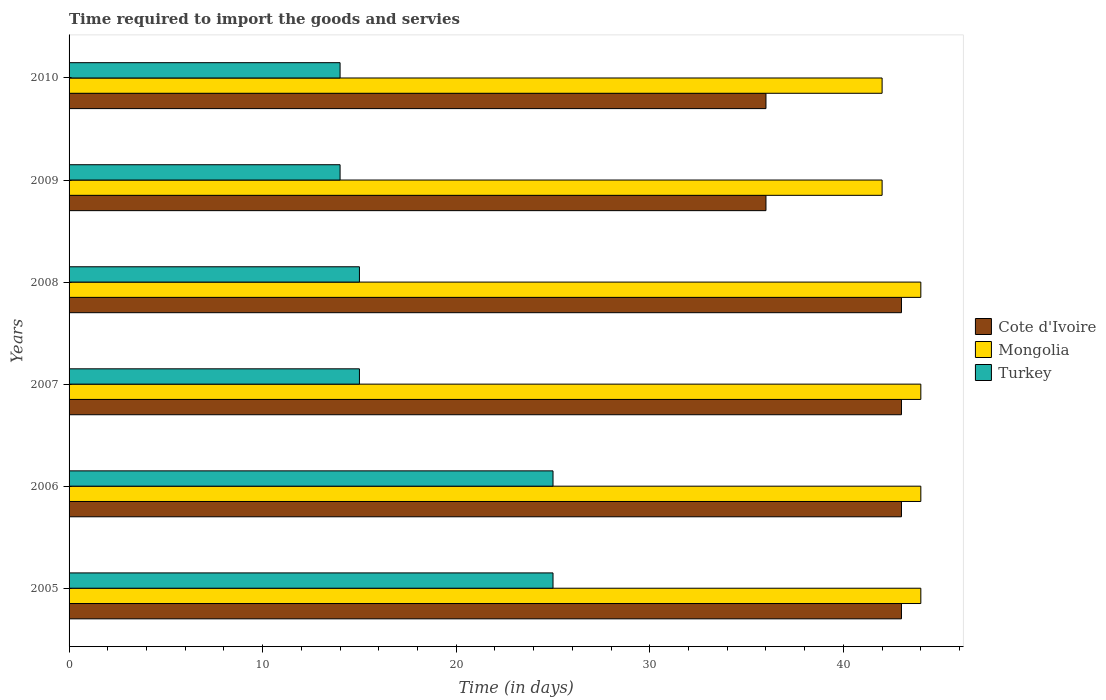How many bars are there on the 6th tick from the bottom?
Your answer should be very brief. 3. In how many cases, is the number of bars for a given year not equal to the number of legend labels?
Your answer should be very brief. 0. What is the number of days required to import the goods and services in Turkey in 2007?
Offer a terse response. 15. Across all years, what is the maximum number of days required to import the goods and services in Turkey?
Offer a terse response. 25. Across all years, what is the minimum number of days required to import the goods and services in Cote d'Ivoire?
Offer a very short reply. 36. In which year was the number of days required to import the goods and services in Turkey maximum?
Ensure brevity in your answer.  2005. In which year was the number of days required to import the goods and services in Cote d'Ivoire minimum?
Keep it short and to the point. 2009. What is the total number of days required to import the goods and services in Cote d'Ivoire in the graph?
Your answer should be compact. 244. What is the difference between the number of days required to import the goods and services in Cote d'Ivoire in 2007 and that in 2008?
Give a very brief answer. 0. What is the difference between the number of days required to import the goods and services in Turkey in 2006 and the number of days required to import the goods and services in Mongolia in 2009?
Provide a short and direct response. -17. What is the average number of days required to import the goods and services in Turkey per year?
Provide a short and direct response. 18. In the year 2010, what is the difference between the number of days required to import the goods and services in Cote d'Ivoire and number of days required to import the goods and services in Turkey?
Make the answer very short. 22. In how many years, is the number of days required to import the goods and services in Turkey greater than 38 days?
Give a very brief answer. 0. What is the ratio of the number of days required to import the goods and services in Cote d'Ivoire in 2009 to that in 2010?
Your answer should be very brief. 1. Is the number of days required to import the goods and services in Cote d'Ivoire in 2005 less than that in 2006?
Give a very brief answer. No. Is the difference between the number of days required to import the goods and services in Cote d'Ivoire in 2005 and 2008 greater than the difference between the number of days required to import the goods and services in Turkey in 2005 and 2008?
Offer a very short reply. No. What is the difference between the highest and the lowest number of days required to import the goods and services in Mongolia?
Provide a succinct answer. 2. What does the 2nd bar from the top in 2009 represents?
Ensure brevity in your answer.  Mongolia. What does the 1st bar from the bottom in 2007 represents?
Provide a short and direct response. Cote d'Ivoire. Is it the case that in every year, the sum of the number of days required to import the goods and services in Mongolia and number of days required to import the goods and services in Turkey is greater than the number of days required to import the goods and services in Cote d'Ivoire?
Your answer should be compact. Yes. How many bars are there?
Your answer should be compact. 18. Are all the bars in the graph horizontal?
Make the answer very short. Yes. How many years are there in the graph?
Provide a succinct answer. 6. Are the values on the major ticks of X-axis written in scientific E-notation?
Ensure brevity in your answer.  No. Does the graph contain any zero values?
Your answer should be very brief. No. Does the graph contain grids?
Ensure brevity in your answer.  No. Where does the legend appear in the graph?
Provide a short and direct response. Center right. How many legend labels are there?
Make the answer very short. 3. What is the title of the graph?
Your answer should be very brief. Time required to import the goods and servies. What is the label or title of the X-axis?
Offer a terse response. Time (in days). What is the Time (in days) in Cote d'Ivoire in 2007?
Ensure brevity in your answer.  43. What is the Time (in days) in Mongolia in 2007?
Provide a short and direct response. 44. What is the Time (in days) in Turkey in 2007?
Your response must be concise. 15. What is the Time (in days) of Cote d'Ivoire in 2008?
Provide a succinct answer. 43. What is the Time (in days) in Turkey in 2008?
Provide a succinct answer. 15. What is the Time (in days) of Cote d'Ivoire in 2009?
Keep it short and to the point. 36. What is the Time (in days) of Cote d'Ivoire in 2010?
Give a very brief answer. 36. What is the Time (in days) of Turkey in 2010?
Provide a short and direct response. 14. Across all years, what is the maximum Time (in days) in Turkey?
Your answer should be compact. 25. Across all years, what is the minimum Time (in days) in Cote d'Ivoire?
Make the answer very short. 36. What is the total Time (in days) of Cote d'Ivoire in the graph?
Your answer should be compact. 244. What is the total Time (in days) of Mongolia in the graph?
Make the answer very short. 260. What is the total Time (in days) of Turkey in the graph?
Provide a succinct answer. 108. What is the difference between the Time (in days) in Turkey in 2005 and that in 2006?
Provide a succinct answer. 0. What is the difference between the Time (in days) of Cote d'Ivoire in 2005 and that in 2007?
Ensure brevity in your answer.  0. What is the difference between the Time (in days) in Mongolia in 2005 and that in 2007?
Give a very brief answer. 0. What is the difference between the Time (in days) of Cote d'Ivoire in 2005 and that in 2008?
Offer a terse response. 0. What is the difference between the Time (in days) in Mongolia in 2005 and that in 2009?
Provide a succinct answer. 2. What is the difference between the Time (in days) in Cote d'Ivoire in 2005 and that in 2010?
Give a very brief answer. 7. What is the difference between the Time (in days) of Turkey in 2005 and that in 2010?
Your response must be concise. 11. What is the difference between the Time (in days) in Turkey in 2006 and that in 2007?
Provide a succinct answer. 10. What is the difference between the Time (in days) in Turkey in 2006 and that in 2008?
Provide a short and direct response. 10. What is the difference between the Time (in days) in Cote d'Ivoire in 2006 and that in 2009?
Your answer should be compact. 7. What is the difference between the Time (in days) of Turkey in 2006 and that in 2009?
Your answer should be compact. 11. What is the difference between the Time (in days) in Cote d'Ivoire in 2006 and that in 2010?
Offer a very short reply. 7. What is the difference between the Time (in days) of Mongolia in 2006 and that in 2010?
Your response must be concise. 2. What is the difference between the Time (in days) in Turkey in 2006 and that in 2010?
Your response must be concise. 11. What is the difference between the Time (in days) of Turkey in 2007 and that in 2008?
Your response must be concise. 0. What is the difference between the Time (in days) of Cote d'Ivoire in 2007 and that in 2009?
Offer a terse response. 7. What is the difference between the Time (in days) in Turkey in 2007 and that in 2009?
Ensure brevity in your answer.  1. What is the difference between the Time (in days) of Cote d'Ivoire in 2007 and that in 2010?
Your response must be concise. 7. What is the difference between the Time (in days) in Mongolia in 2007 and that in 2010?
Keep it short and to the point. 2. What is the difference between the Time (in days) in Mongolia in 2008 and that in 2009?
Your response must be concise. 2. What is the difference between the Time (in days) of Turkey in 2008 and that in 2009?
Your answer should be compact. 1. What is the difference between the Time (in days) in Cote d'Ivoire in 2008 and that in 2010?
Make the answer very short. 7. What is the difference between the Time (in days) in Mongolia in 2008 and that in 2010?
Provide a short and direct response. 2. What is the difference between the Time (in days) in Mongolia in 2009 and that in 2010?
Your answer should be very brief. 0. What is the difference between the Time (in days) in Cote d'Ivoire in 2005 and the Time (in days) in Turkey in 2006?
Provide a succinct answer. 18. What is the difference between the Time (in days) of Cote d'Ivoire in 2005 and the Time (in days) of Mongolia in 2007?
Give a very brief answer. -1. What is the difference between the Time (in days) in Cote d'Ivoire in 2005 and the Time (in days) in Mongolia in 2008?
Ensure brevity in your answer.  -1. What is the difference between the Time (in days) of Cote d'Ivoire in 2005 and the Time (in days) of Turkey in 2008?
Offer a terse response. 28. What is the difference between the Time (in days) of Mongolia in 2005 and the Time (in days) of Turkey in 2008?
Your answer should be very brief. 29. What is the difference between the Time (in days) of Cote d'Ivoire in 2005 and the Time (in days) of Turkey in 2009?
Ensure brevity in your answer.  29. What is the difference between the Time (in days) of Cote d'Ivoire in 2005 and the Time (in days) of Mongolia in 2010?
Keep it short and to the point. 1. What is the difference between the Time (in days) of Cote d'Ivoire in 2005 and the Time (in days) of Turkey in 2010?
Your answer should be very brief. 29. What is the difference between the Time (in days) in Mongolia in 2005 and the Time (in days) in Turkey in 2010?
Give a very brief answer. 30. What is the difference between the Time (in days) of Cote d'Ivoire in 2006 and the Time (in days) of Mongolia in 2007?
Ensure brevity in your answer.  -1. What is the difference between the Time (in days) of Mongolia in 2006 and the Time (in days) of Turkey in 2007?
Provide a succinct answer. 29. What is the difference between the Time (in days) of Cote d'Ivoire in 2006 and the Time (in days) of Mongolia in 2008?
Offer a very short reply. -1. What is the difference between the Time (in days) in Mongolia in 2006 and the Time (in days) in Turkey in 2008?
Offer a very short reply. 29. What is the difference between the Time (in days) of Mongolia in 2006 and the Time (in days) of Turkey in 2009?
Provide a short and direct response. 30. What is the difference between the Time (in days) of Mongolia in 2007 and the Time (in days) of Turkey in 2008?
Offer a very short reply. 29. What is the difference between the Time (in days) in Cote d'Ivoire in 2007 and the Time (in days) in Mongolia in 2009?
Your answer should be very brief. 1. What is the difference between the Time (in days) of Cote d'Ivoire in 2007 and the Time (in days) of Turkey in 2009?
Make the answer very short. 29. What is the difference between the Time (in days) of Cote d'Ivoire in 2008 and the Time (in days) of Turkey in 2009?
Make the answer very short. 29. What is the difference between the Time (in days) of Mongolia in 2008 and the Time (in days) of Turkey in 2010?
Your answer should be very brief. 30. What is the difference between the Time (in days) in Cote d'Ivoire in 2009 and the Time (in days) in Mongolia in 2010?
Provide a short and direct response. -6. What is the difference between the Time (in days) of Cote d'Ivoire in 2009 and the Time (in days) of Turkey in 2010?
Provide a short and direct response. 22. What is the average Time (in days) of Cote d'Ivoire per year?
Provide a succinct answer. 40.67. What is the average Time (in days) of Mongolia per year?
Keep it short and to the point. 43.33. In the year 2005, what is the difference between the Time (in days) in Cote d'Ivoire and Time (in days) in Turkey?
Offer a terse response. 18. In the year 2005, what is the difference between the Time (in days) of Mongolia and Time (in days) of Turkey?
Make the answer very short. 19. In the year 2006, what is the difference between the Time (in days) in Cote d'Ivoire and Time (in days) in Mongolia?
Offer a terse response. -1. In the year 2006, what is the difference between the Time (in days) in Cote d'Ivoire and Time (in days) in Turkey?
Your answer should be very brief. 18. In the year 2007, what is the difference between the Time (in days) in Mongolia and Time (in days) in Turkey?
Offer a very short reply. 29. In the year 2008, what is the difference between the Time (in days) of Mongolia and Time (in days) of Turkey?
Offer a very short reply. 29. In the year 2009, what is the difference between the Time (in days) of Cote d'Ivoire and Time (in days) of Mongolia?
Provide a short and direct response. -6. In the year 2009, what is the difference between the Time (in days) in Cote d'Ivoire and Time (in days) in Turkey?
Offer a terse response. 22. In the year 2010, what is the difference between the Time (in days) of Mongolia and Time (in days) of Turkey?
Your answer should be compact. 28. What is the ratio of the Time (in days) in Cote d'Ivoire in 2005 to that in 2006?
Offer a terse response. 1. What is the ratio of the Time (in days) in Mongolia in 2005 to that in 2006?
Give a very brief answer. 1. What is the ratio of the Time (in days) of Turkey in 2005 to that in 2006?
Make the answer very short. 1. What is the ratio of the Time (in days) of Cote d'Ivoire in 2005 to that in 2007?
Offer a very short reply. 1. What is the ratio of the Time (in days) of Mongolia in 2005 to that in 2007?
Ensure brevity in your answer.  1. What is the ratio of the Time (in days) in Turkey in 2005 to that in 2007?
Ensure brevity in your answer.  1.67. What is the ratio of the Time (in days) in Mongolia in 2005 to that in 2008?
Provide a succinct answer. 1. What is the ratio of the Time (in days) in Cote d'Ivoire in 2005 to that in 2009?
Your answer should be very brief. 1.19. What is the ratio of the Time (in days) of Mongolia in 2005 to that in 2009?
Ensure brevity in your answer.  1.05. What is the ratio of the Time (in days) of Turkey in 2005 to that in 2009?
Your response must be concise. 1.79. What is the ratio of the Time (in days) of Cote d'Ivoire in 2005 to that in 2010?
Give a very brief answer. 1.19. What is the ratio of the Time (in days) of Mongolia in 2005 to that in 2010?
Make the answer very short. 1.05. What is the ratio of the Time (in days) in Turkey in 2005 to that in 2010?
Keep it short and to the point. 1.79. What is the ratio of the Time (in days) of Turkey in 2006 to that in 2007?
Provide a short and direct response. 1.67. What is the ratio of the Time (in days) of Mongolia in 2006 to that in 2008?
Ensure brevity in your answer.  1. What is the ratio of the Time (in days) in Cote d'Ivoire in 2006 to that in 2009?
Your response must be concise. 1.19. What is the ratio of the Time (in days) in Mongolia in 2006 to that in 2009?
Your answer should be compact. 1.05. What is the ratio of the Time (in days) of Turkey in 2006 to that in 2009?
Provide a short and direct response. 1.79. What is the ratio of the Time (in days) of Cote d'Ivoire in 2006 to that in 2010?
Give a very brief answer. 1.19. What is the ratio of the Time (in days) in Mongolia in 2006 to that in 2010?
Your answer should be compact. 1.05. What is the ratio of the Time (in days) of Turkey in 2006 to that in 2010?
Offer a terse response. 1.79. What is the ratio of the Time (in days) in Mongolia in 2007 to that in 2008?
Offer a terse response. 1. What is the ratio of the Time (in days) of Cote d'Ivoire in 2007 to that in 2009?
Offer a terse response. 1.19. What is the ratio of the Time (in days) in Mongolia in 2007 to that in 2009?
Your answer should be compact. 1.05. What is the ratio of the Time (in days) of Turkey in 2007 to that in 2009?
Give a very brief answer. 1.07. What is the ratio of the Time (in days) in Cote d'Ivoire in 2007 to that in 2010?
Your response must be concise. 1.19. What is the ratio of the Time (in days) in Mongolia in 2007 to that in 2010?
Your response must be concise. 1.05. What is the ratio of the Time (in days) of Turkey in 2007 to that in 2010?
Your answer should be very brief. 1.07. What is the ratio of the Time (in days) of Cote d'Ivoire in 2008 to that in 2009?
Your response must be concise. 1.19. What is the ratio of the Time (in days) in Mongolia in 2008 to that in 2009?
Keep it short and to the point. 1.05. What is the ratio of the Time (in days) of Turkey in 2008 to that in 2009?
Your answer should be very brief. 1.07. What is the ratio of the Time (in days) of Cote d'Ivoire in 2008 to that in 2010?
Your answer should be compact. 1.19. What is the ratio of the Time (in days) in Mongolia in 2008 to that in 2010?
Your answer should be very brief. 1.05. What is the ratio of the Time (in days) in Turkey in 2008 to that in 2010?
Your answer should be compact. 1.07. What is the difference between the highest and the second highest Time (in days) of Turkey?
Your answer should be very brief. 0. What is the difference between the highest and the lowest Time (in days) of Cote d'Ivoire?
Offer a terse response. 7. What is the difference between the highest and the lowest Time (in days) of Mongolia?
Your answer should be very brief. 2. 